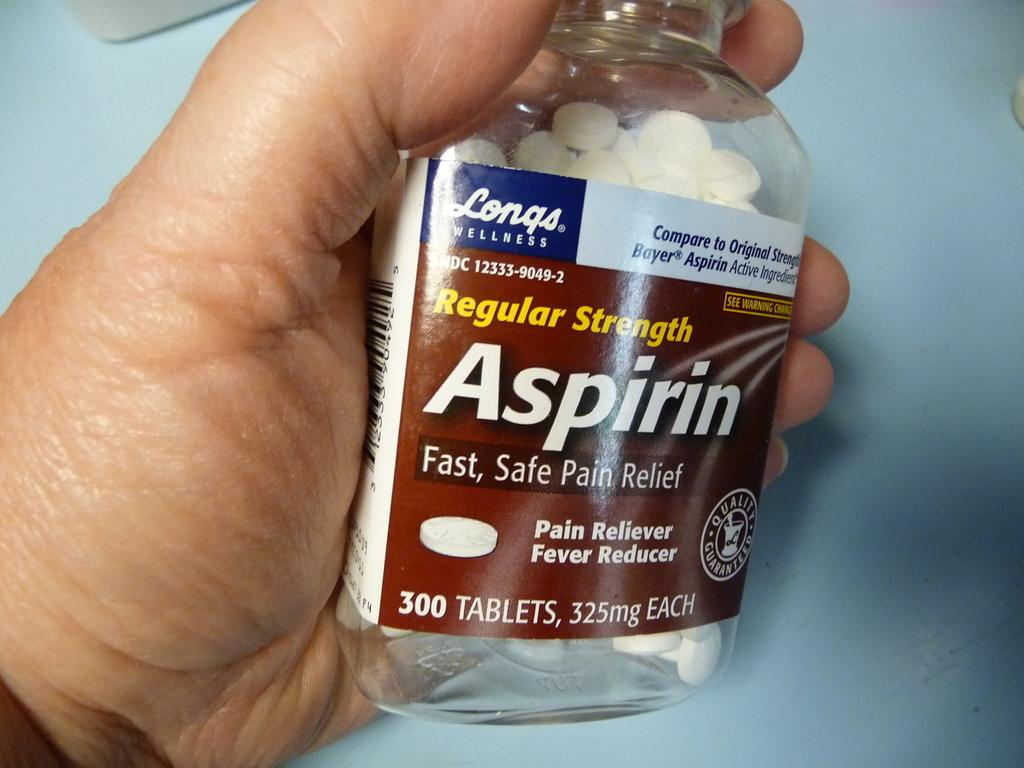What is the main subject of the image? The main subject of the image is a human hand. What is the hand holding in the image? The hand is holding a bottle. What type of songs can be heard coming from the bottle in the image? There is no indication in the image that the bottle is producing any sounds, let alone songs. 